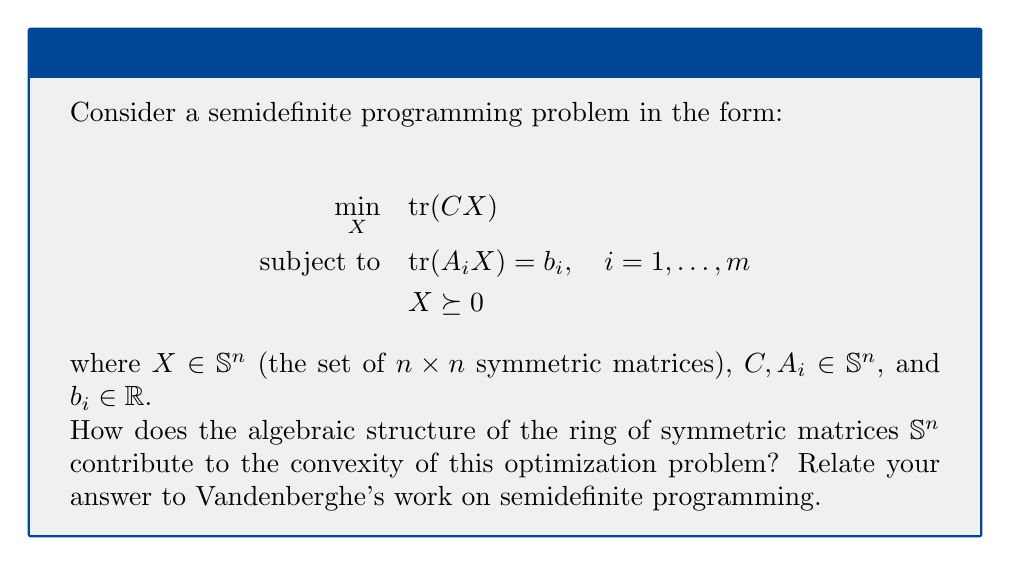Provide a solution to this math problem. To answer this question, we need to consider the following steps:

1) The ring structure of $\mathbb{S}^n$:
   $\mathbb{S}^n$ forms a ring under matrix addition and multiplication. It's a subring of the ring of all $n \times n$ matrices.

2) Positive semidefiniteness:
   The constraint $X \succeq 0$ means $X$ is positive semidefinite. In ring theory, this is equivalent to saying $X$ belongs to the cone of positive semidefinite matrices within $\mathbb{S}^n$.

3) Convexity of the problem:
   The objective function $\text{tr}(CX)$ is linear in $X$. The constraints $\text{tr}(A_iX) = b_i$ are also linear. The key to convexity lies in the positive semidefinite constraint.

4) Positive semidefinite cone:
   The set of positive semidefinite matrices forms a convex cone in $\mathbb{S}^n$. This is a crucial property that Vandenberghe has extensively used in his work on semidefinite programming.

5) Ring operations and convexity:
   The ring operations (addition and multiplication) in $\mathbb{S}^n$ preserve the positive semidefinite property. If $X_1, X_2 \succeq 0$, then $X_1 + X_2 \succeq 0$ and $X_1X_2 \succeq 0$.

6) Vandenberghe's contributions:
   Vandenberghe, along with Boyd, has shown how the algebraic properties of $\mathbb{S}^n$ can be exploited to develop efficient interior-point methods for semidefinite programming. The ring structure allows for matrix factorizations and efficient linear algebra operations.

7) Duality:
   The ring structure of $\mathbb{S}^n$ also plays a crucial role in the duality theory of semidefinite programming, another area where Vandenberghe has made significant contributions.

Therefore, the ring structure of $\mathbb{S}^n$, particularly the properties of the positive semidefinite cone within this ring, is fundamental to the convexity of semidefinite programming problems and the development of efficient algorithms to solve them.
Answer: The positive semidefinite cone in $\mathbb{S}^n$ ensures convexity, while ring operations preserve positive semidefiniteness, enabling efficient optimization algorithms. 